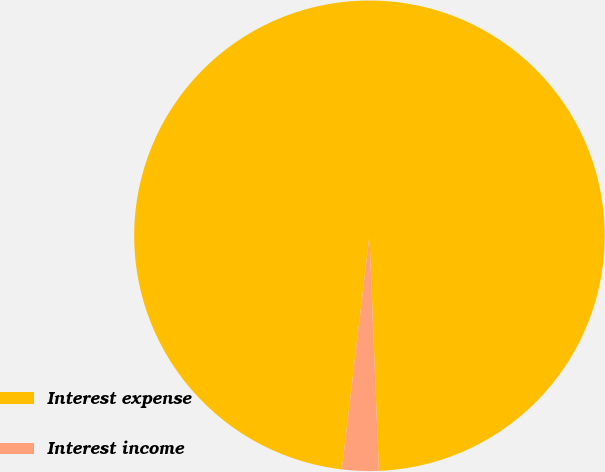<chart> <loc_0><loc_0><loc_500><loc_500><pie_chart><fcel>Interest expense<fcel>Interest income<nl><fcel>97.49%<fcel>2.51%<nl></chart> 